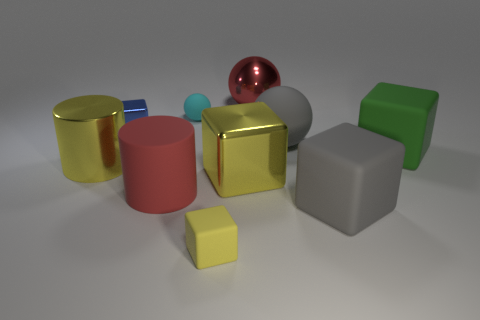There is a small matte thing in front of the ball that is in front of the tiny cyan rubber object; what is its color?
Your answer should be very brief. Yellow. There is a big matte ball; is its color the same as the small block that is on the left side of the tiny rubber ball?
Give a very brief answer. No. What material is the small thing that is behind the yellow shiny block and on the right side of the blue metallic block?
Provide a short and direct response. Rubber. Is there a red rubber block that has the same size as the metal cylinder?
Give a very brief answer. No. There is another red cylinder that is the same size as the metal cylinder; what is it made of?
Make the answer very short. Rubber. What number of things are in front of the big green matte cube?
Provide a short and direct response. 5. Is the shape of the large yellow object that is right of the small yellow rubber cube the same as  the yellow rubber thing?
Give a very brief answer. Yes. Are there any big purple rubber objects that have the same shape as the large green object?
Keep it short and to the point. No. What material is the small object that is the same color as the big metallic block?
Ensure brevity in your answer.  Rubber. What is the shape of the gray object that is behind the yellow metallic thing left of the small blue metallic thing?
Offer a terse response. Sphere. 